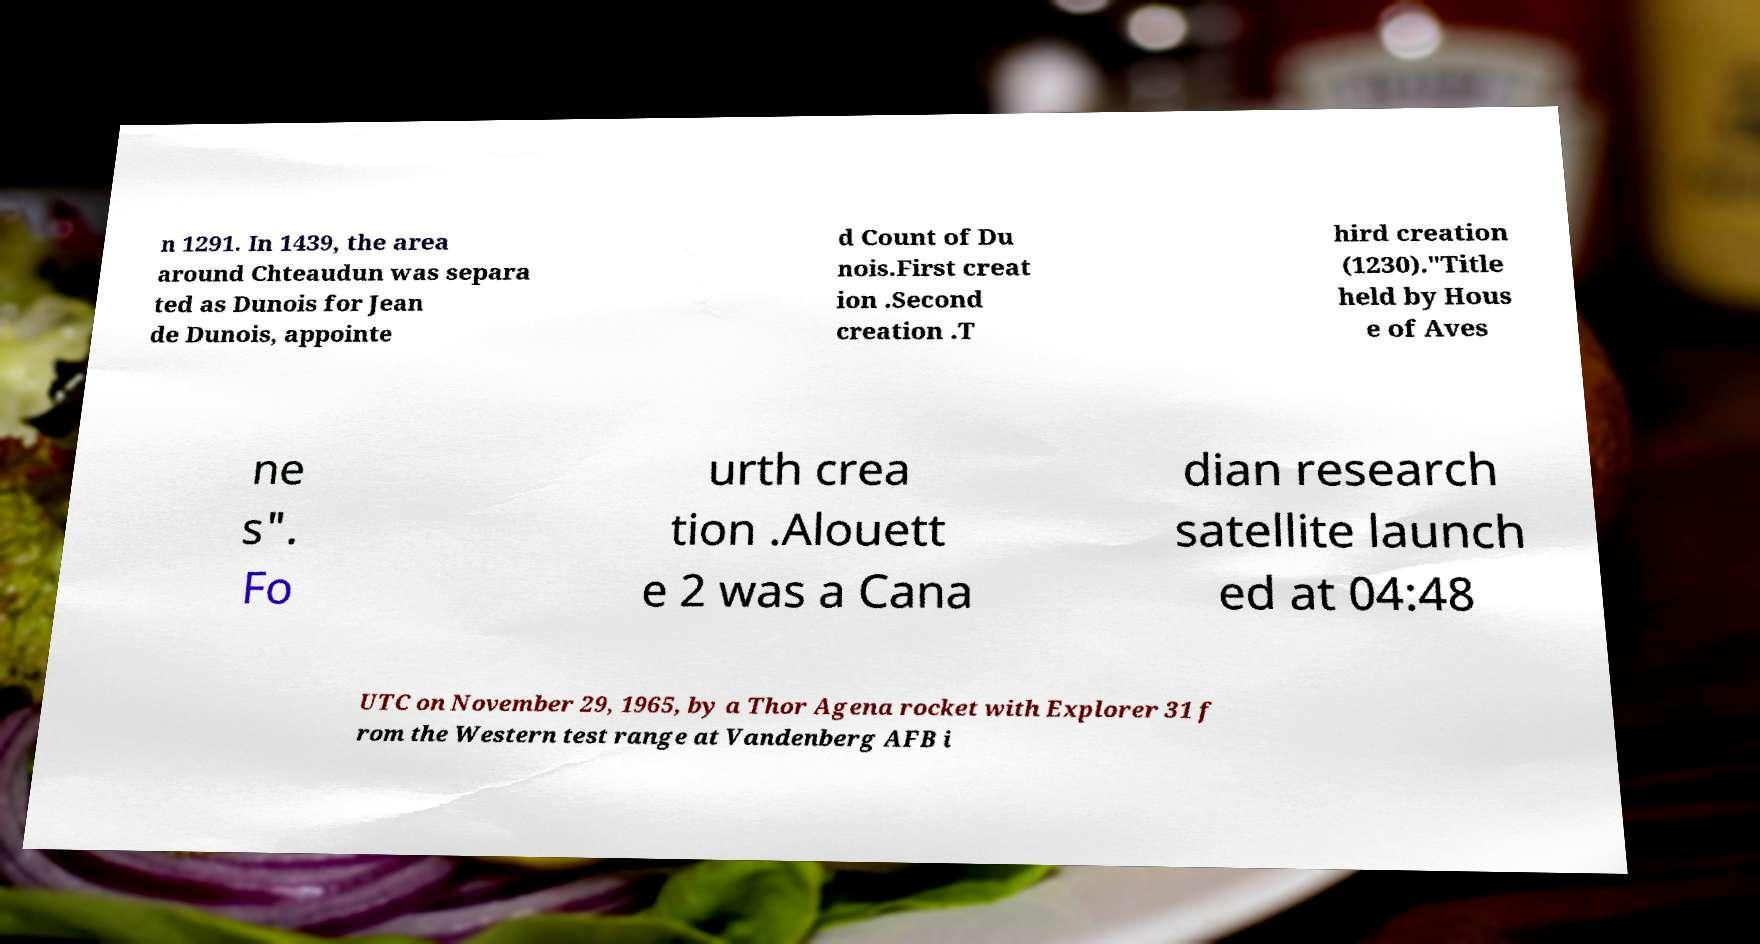Could you extract and type out the text from this image? n 1291. In 1439, the area around Chteaudun was separa ted as Dunois for Jean de Dunois, appointe d Count of Du nois.First creat ion .Second creation .T hird creation (1230)."Title held by Hous e of Aves ne s". Fo urth crea tion .Alouett e 2 was a Cana dian research satellite launch ed at 04:48 UTC on November 29, 1965, by a Thor Agena rocket with Explorer 31 f rom the Western test range at Vandenberg AFB i 